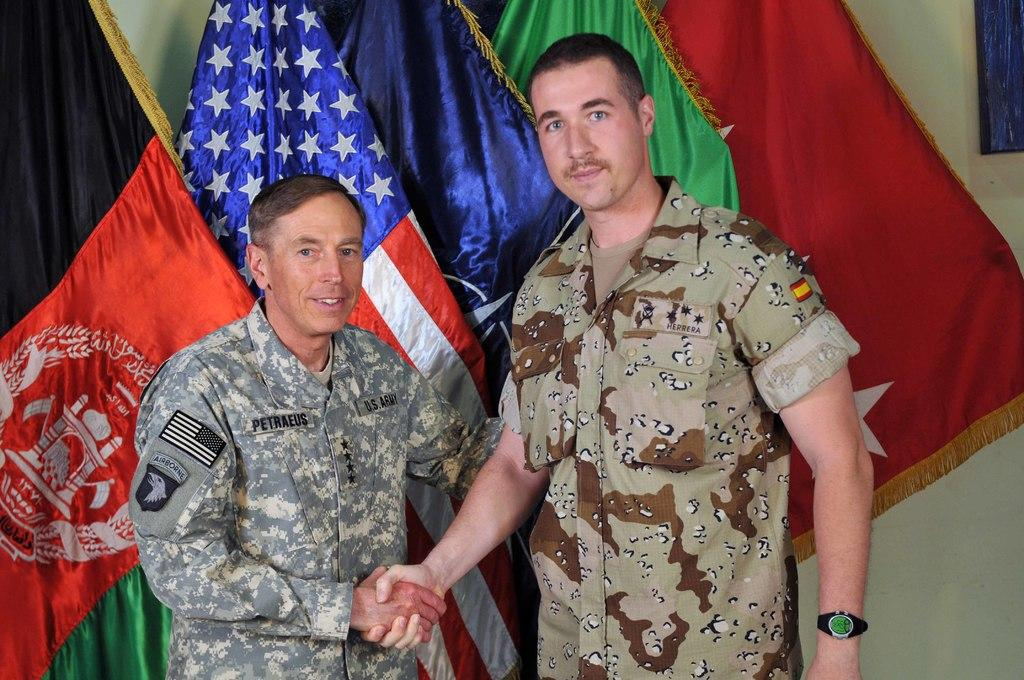<image>
Offer a succinct explanation of the picture presented. Two soldiers named Petraeus and Herrera, dressed in U.S. Army attire, are shaking hands in front of some flags. 